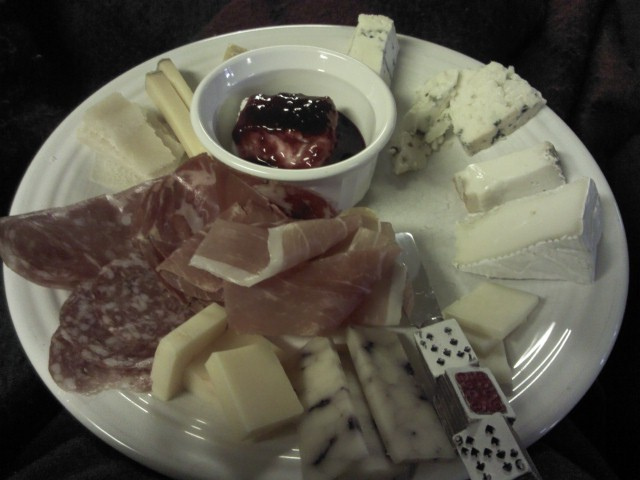What are the different types of cheese presented on the plate, and which one appears to be the most flavorful? Based on the image, there appears to be an assortment of cheeses including what looks like cheddar, brie, and a blue cheese. While flavor is subjective, blue cheese is often considered to have a strong and distinct taste due to the presence of blue mold that gives it a sharp and tangy flavor. 